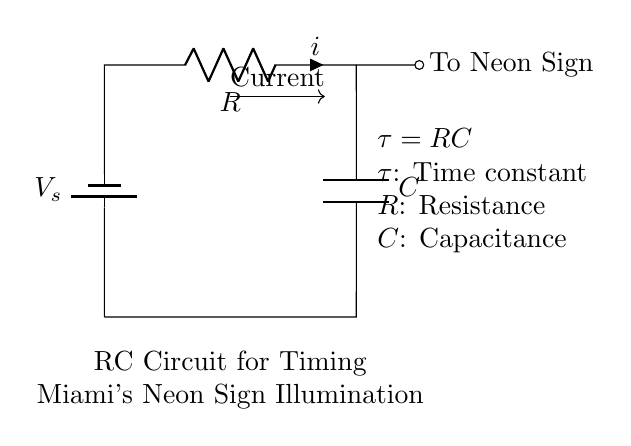What is the main function of the capacitor in this circuit? The capacitor stores electrical energy and releases it to control the timing of the neon sign illumination.
Answer: Timing What does the symbol $R$ represent? In the circuit diagram, $R$ represents the resistance in ohms, which controls how much current flows and how quickly the capacitor charges.
Answer: Resistance What is the equation given for the time constant? The equation provided in the circuit diagram is $\tau = RC$, where $\tau$ (tau) is the time constant that determines how long it takes for the capacitor to charge to approximately 63% of the supply voltage.
Answer: Tau equals RC How does increasing the resistance affect the time constant? Increasing the resistance $R$ in the time constant equation $\tau = RC$ will result in a longer time constant, meaning the neon sign will take longer to illuminate.
Answer: Longer time What does the arrow labeled "Current" indicate? The arrow labeled "Current" indicates the direction in which the current flows through the circuit, from the battery to the resistor and capacitor before reaching the neon sign.
Answer: Current direction What will happen to the neon sign if the capacitance is increased? If the capacitance $C$ is increased, based on the equation $\tau = RC$, the time constant $\tau$ will increase, causing the neon sign to illuminate after a longer duration.
Answer: Illuminate later 